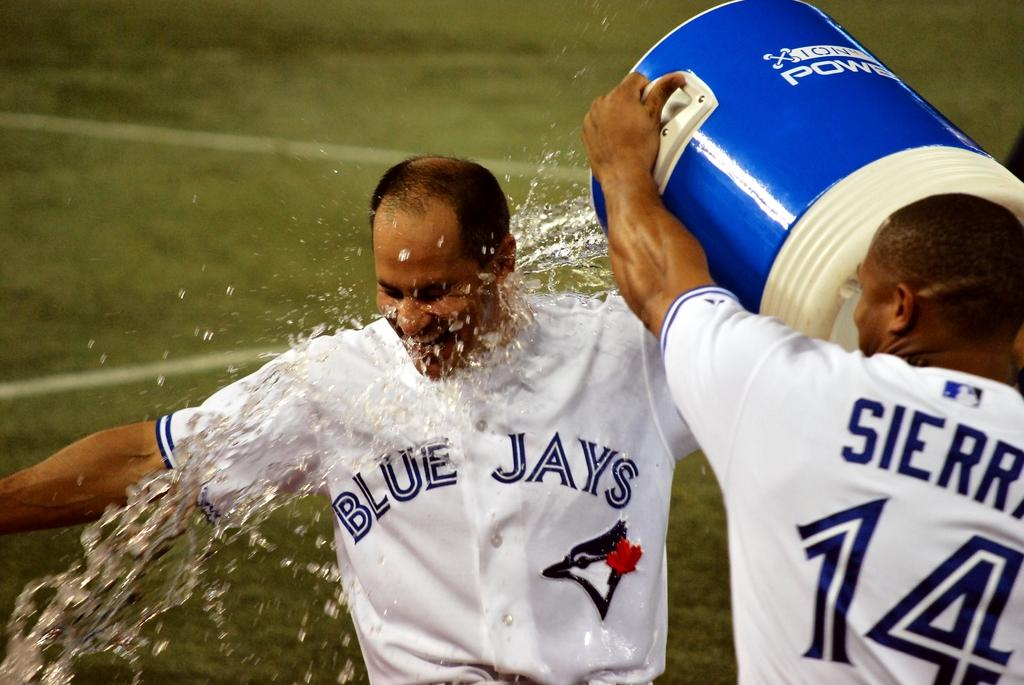<image>
Create a compact narrative representing the image presented. a blue jays player getting liquid poured on them 